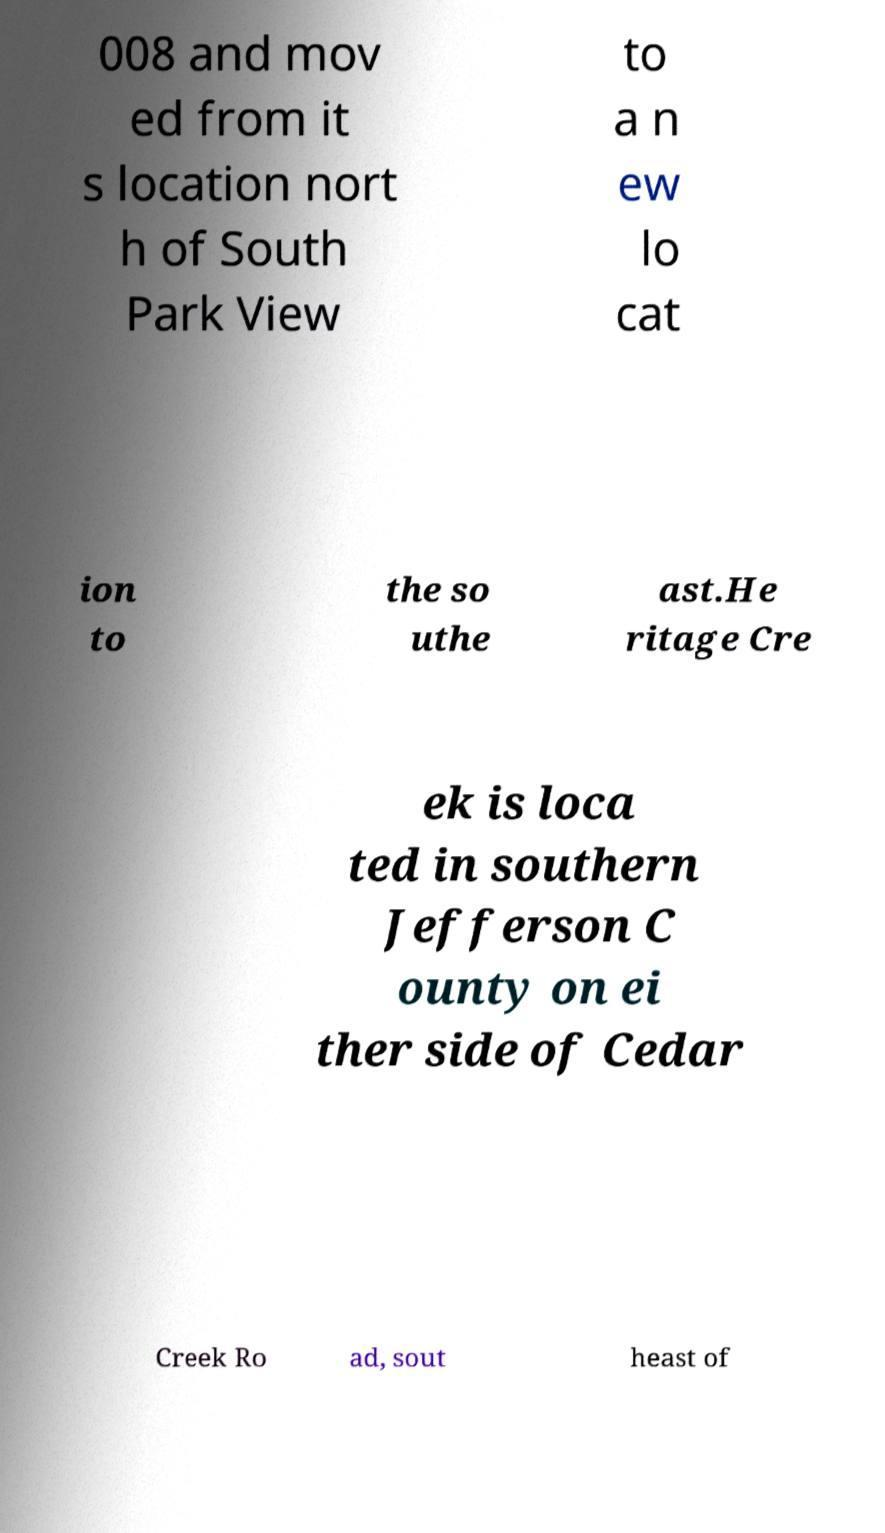Can you read and provide the text displayed in the image?This photo seems to have some interesting text. Can you extract and type it out for me? 008 and mov ed from it s location nort h of South Park View to a n ew lo cat ion to the so uthe ast.He ritage Cre ek is loca ted in southern Jefferson C ounty on ei ther side of Cedar Creek Ro ad, sout heast of 